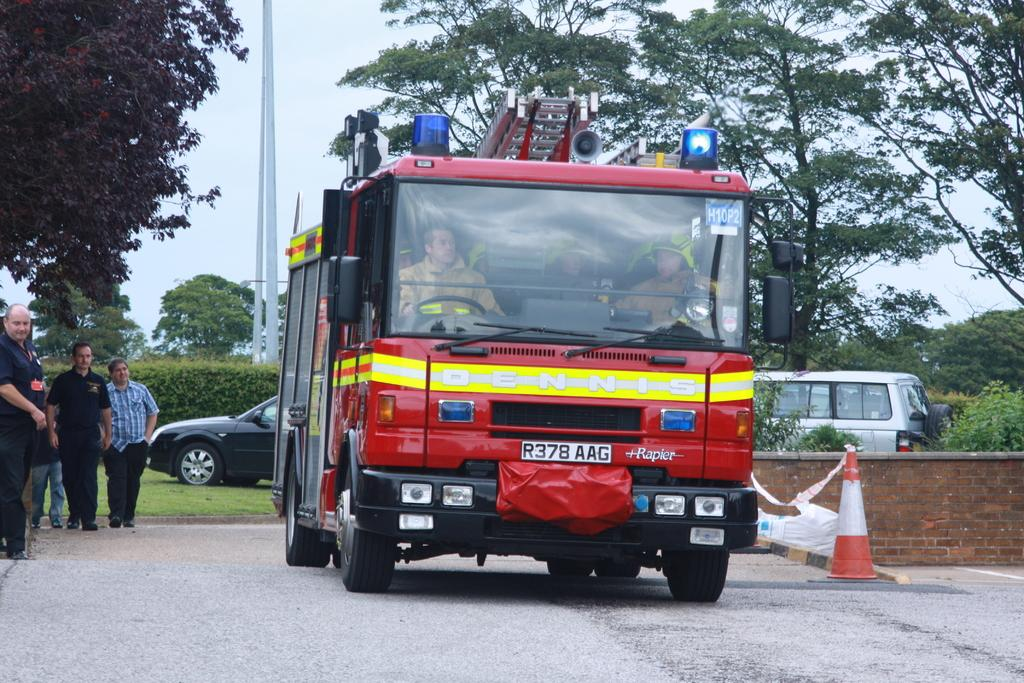What types of objects can be seen in the image? There are vehicles and a traffic cone present in the image. Are there any living beings in the image? Yes, there are people in the image. What can be seen in the background of the image? There are plants, trees, poles, and the sky visible in the background of the image. What type of jam is being spread on the traffic cone in the image? There is no jam present in the image, and the traffic cone is not being used for spreading jam. What arithmetic problem can be solved using the number of vehicles in the image? There is no arithmetic problem mentioned or implied in the image, as it only shows vehicles and a traffic cone. 